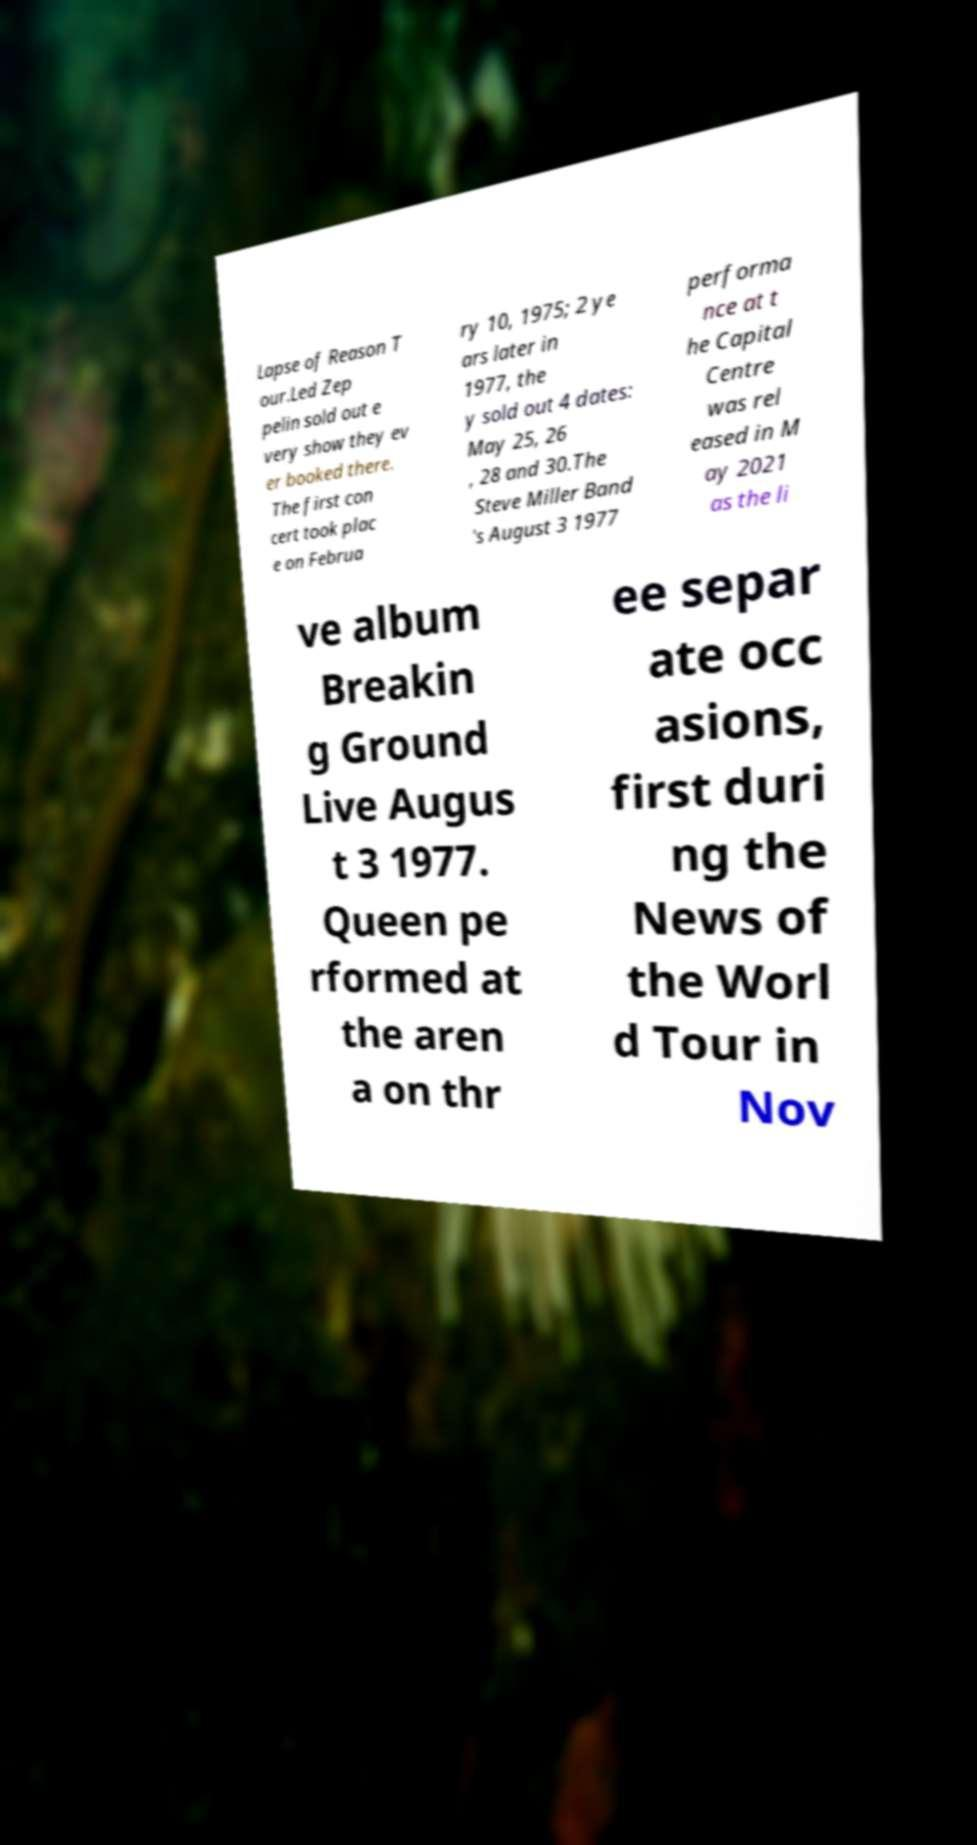What messages or text are displayed in this image? I need them in a readable, typed format. Lapse of Reason T our.Led Zep pelin sold out e very show they ev er booked there. The first con cert took plac e on Februa ry 10, 1975; 2 ye ars later in 1977, the y sold out 4 dates: May 25, 26 , 28 and 30.The Steve Miller Band 's August 3 1977 performa nce at t he Capital Centre was rel eased in M ay 2021 as the li ve album Breakin g Ground Live Augus t 3 1977. Queen pe rformed at the aren a on thr ee separ ate occ asions, first duri ng the News of the Worl d Tour in Nov 